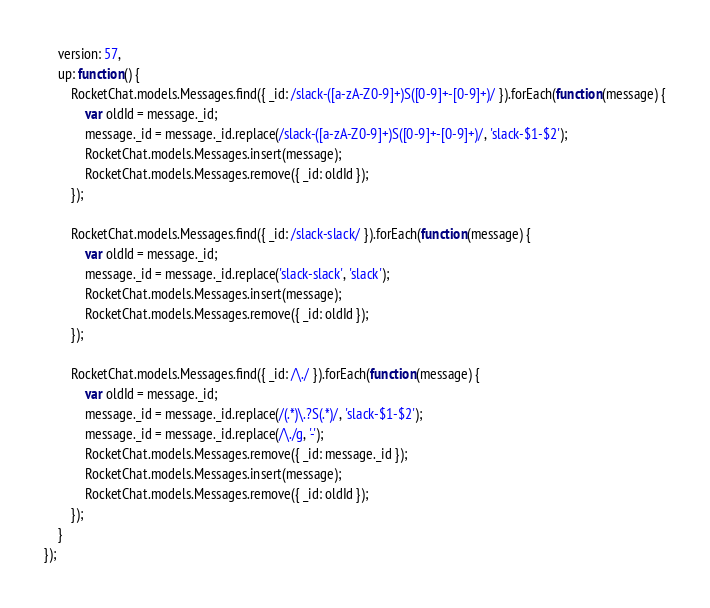<code> <loc_0><loc_0><loc_500><loc_500><_JavaScript_>	version: 57,
	up: function() {
		RocketChat.models.Messages.find({ _id: /slack-([a-zA-Z0-9]+)S([0-9]+-[0-9]+)/ }).forEach(function(message) {
			var oldId = message._id;
			message._id = message._id.replace(/slack-([a-zA-Z0-9]+)S([0-9]+-[0-9]+)/, 'slack-$1-$2');
			RocketChat.models.Messages.insert(message);
			RocketChat.models.Messages.remove({ _id: oldId });
		});

		RocketChat.models.Messages.find({ _id: /slack-slack/ }).forEach(function(message) {
			var oldId = message._id;
			message._id = message._id.replace('slack-slack', 'slack');
			RocketChat.models.Messages.insert(message);
			RocketChat.models.Messages.remove({ _id: oldId });
		});

		RocketChat.models.Messages.find({ _id: /\./ }).forEach(function(message) {
			var oldId = message._id;
			message._id = message._id.replace(/(.*)\.?S(.*)/, 'slack-$1-$2');
			message._id = message._id.replace(/\./g, '-');
			RocketChat.models.Messages.remove({ _id: message._id });
			RocketChat.models.Messages.insert(message);
			RocketChat.models.Messages.remove({ _id: oldId });
		});
	}
});
</code> 